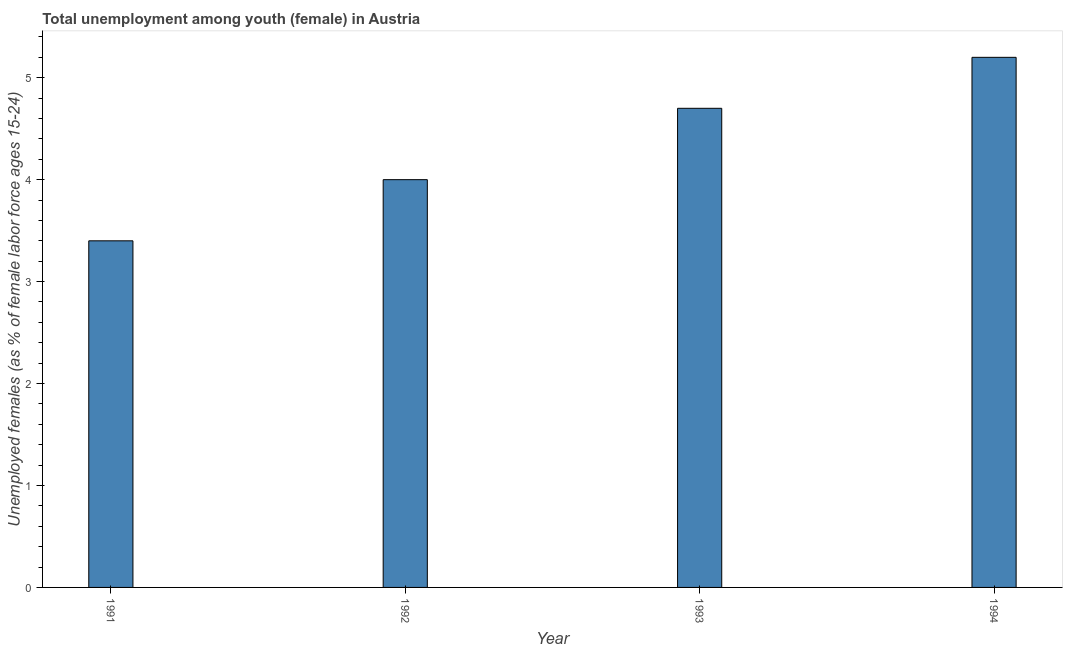Does the graph contain grids?
Your response must be concise. No. What is the title of the graph?
Provide a succinct answer. Total unemployment among youth (female) in Austria. What is the label or title of the Y-axis?
Offer a terse response. Unemployed females (as % of female labor force ages 15-24). What is the unemployed female youth population in 1993?
Offer a very short reply. 4.7. Across all years, what is the maximum unemployed female youth population?
Make the answer very short. 5.2. Across all years, what is the minimum unemployed female youth population?
Your response must be concise. 3.4. In which year was the unemployed female youth population minimum?
Provide a short and direct response. 1991. What is the sum of the unemployed female youth population?
Make the answer very short. 17.3. What is the average unemployed female youth population per year?
Provide a succinct answer. 4.33. What is the median unemployed female youth population?
Your answer should be very brief. 4.35. What is the ratio of the unemployed female youth population in 1992 to that in 1993?
Provide a succinct answer. 0.85. Is the unemployed female youth population in 1992 less than that in 1993?
Provide a short and direct response. Yes. What is the difference between the highest and the lowest unemployed female youth population?
Offer a very short reply. 1.8. Are the values on the major ticks of Y-axis written in scientific E-notation?
Offer a very short reply. No. What is the Unemployed females (as % of female labor force ages 15-24) in 1991?
Offer a very short reply. 3.4. What is the Unemployed females (as % of female labor force ages 15-24) of 1992?
Offer a very short reply. 4. What is the Unemployed females (as % of female labor force ages 15-24) in 1993?
Provide a succinct answer. 4.7. What is the Unemployed females (as % of female labor force ages 15-24) of 1994?
Offer a terse response. 5.2. What is the difference between the Unemployed females (as % of female labor force ages 15-24) in 1991 and 1994?
Your answer should be very brief. -1.8. What is the ratio of the Unemployed females (as % of female labor force ages 15-24) in 1991 to that in 1992?
Your answer should be very brief. 0.85. What is the ratio of the Unemployed females (as % of female labor force ages 15-24) in 1991 to that in 1993?
Give a very brief answer. 0.72. What is the ratio of the Unemployed females (as % of female labor force ages 15-24) in 1991 to that in 1994?
Make the answer very short. 0.65. What is the ratio of the Unemployed females (as % of female labor force ages 15-24) in 1992 to that in 1993?
Keep it short and to the point. 0.85. What is the ratio of the Unemployed females (as % of female labor force ages 15-24) in 1992 to that in 1994?
Ensure brevity in your answer.  0.77. What is the ratio of the Unemployed females (as % of female labor force ages 15-24) in 1993 to that in 1994?
Make the answer very short. 0.9. 